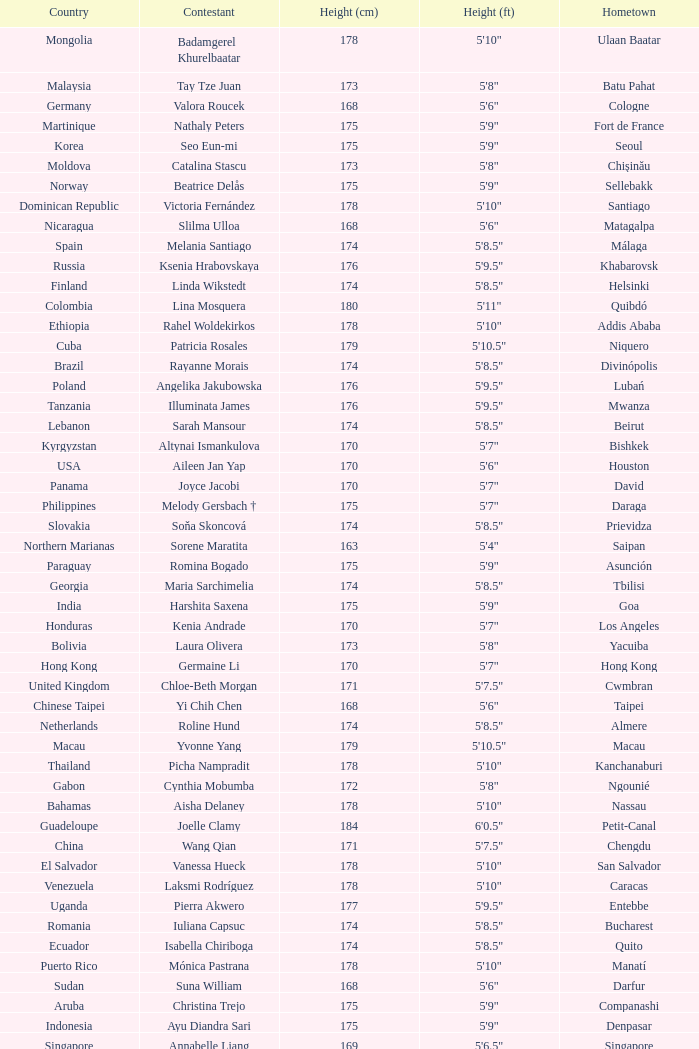What is Cynthia Mobumba's height? 5'8". 